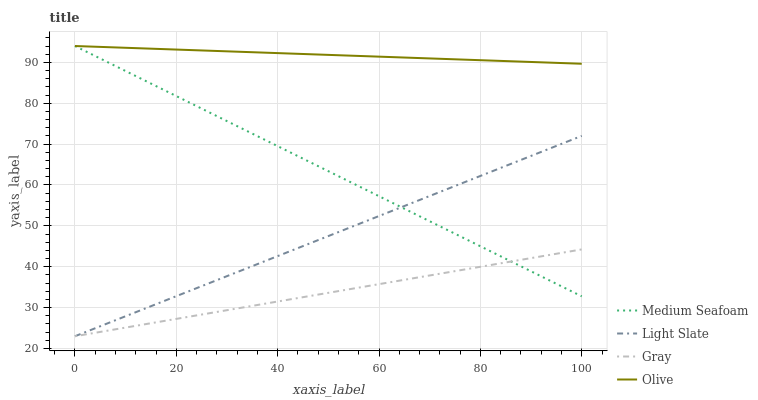Does Gray have the minimum area under the curve?
Answer yes or no. Yes. Does Olive have the maximum area under the curve?
Answer yes or no. Yes. Does Medium Seafoam have the minimum area under the curve?
Answer yes or no. No. Does Medium Seafoam have the maximum area under the curve?
Answer yes or no. No. Is Olive the smoothest?
Answer yes or no. Yes. Is Medium Seafoam the roughest?
Answer yes or no. Yes. Is Gray the smoothest?
Answer yes or no. No. Is Gray the roughest?
Answer yes or no. No. Does Light Slate have the lowest value?
Answer yes or no. Yes. Does Medium Seafoam have the lowest value?
Answer yes or no. No. Does Olive have the highest value?
Answer yes or no. Yes. Does Gray have the highest value?
Answer yes or no. No. Is Gray less than Olive?
Answer yes or no. Yes. Is Olive greater than Light Slate?
Answer yes or no. Yes. Does Medium Seafoam intersect Gray?
Answer yes or no. Yes. Is Medium Seafoam less than Gray?
Answer yes or no. No. Is Medium Seafoam greater than Gray?
Answer yes or no. No. Does Gray intersect Olive?
Answer yes or no. No. 